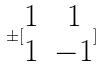<formula> <loc_0><loc_0><loc_500><loc_500>\pm [ \begin{matrix} 1 & 1 \\ 1 & - 1 \end{matrix} ]</formula> 